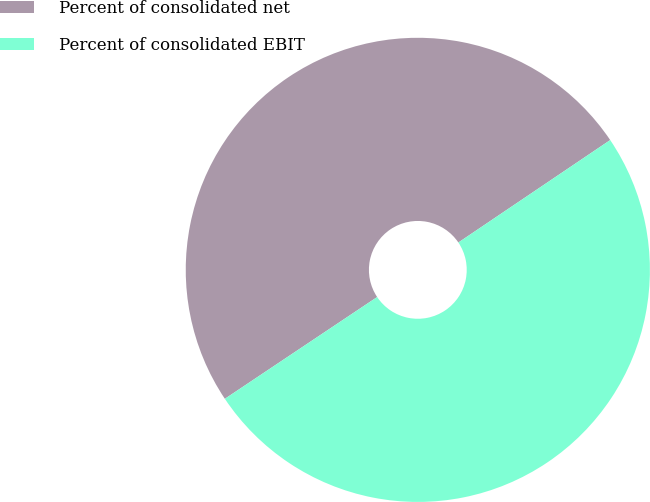<chart> <loc_0><loc_0><loc_500><loc_500><pie_chart><fcel>Percent of consolidated net<fcel>Percent of consolidated EBIT<nl><fcel>49.93%<fcel>50.07%<nl></chart> 